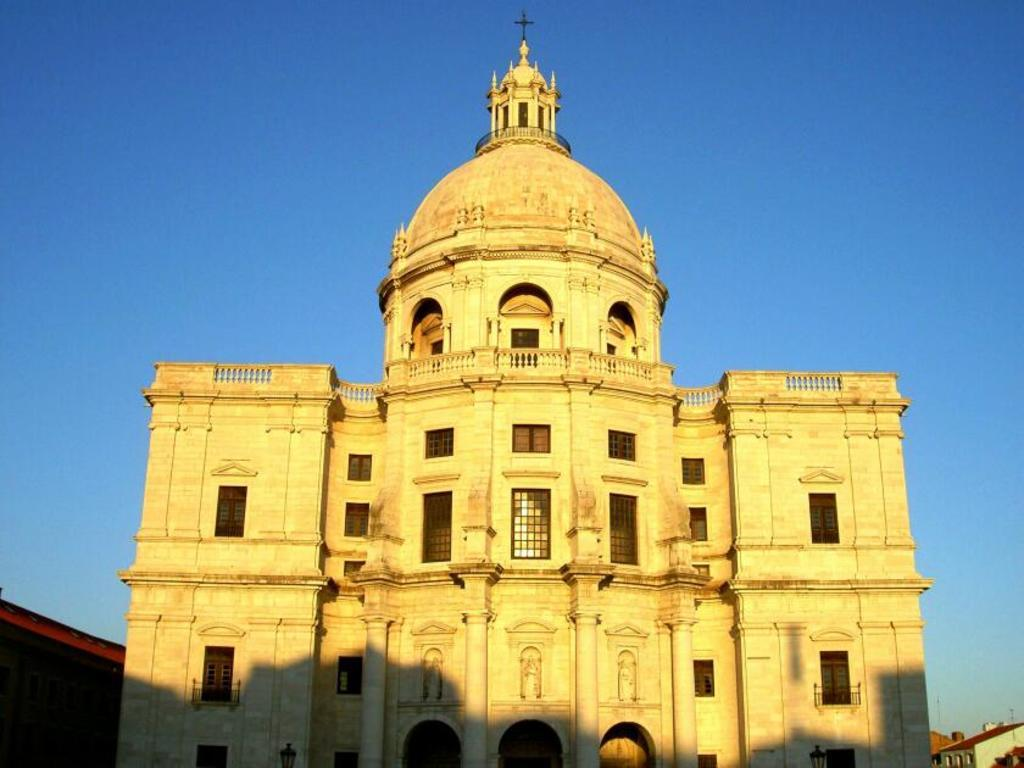What type of structure is visible in the image? There is a building in the image. What color is the sky in the image? The sky is blue in the image. Where is the box located in the image? There is no box present in the image. What type of seat is visible in the image? There is no seat present in the image. 